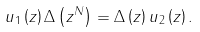<formula> <loc_0><loc_0><loc_500><loc_500>u _ { 1 } \left ( z \right ) \Delta \left ( z ^ { N } \right ) = \Delta \left ( z \right ) u _ { 2 } \left ( z \right ) .</formula> 